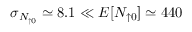<formula> <loc_0><loc_0><loc_500><loc_500>\sigma _ { N _ { \uparrow 0 } } \simeq 8 . 1 \ll E [ N _ { \uparrow 0 } ] \simeq 4 4 0</formula> 